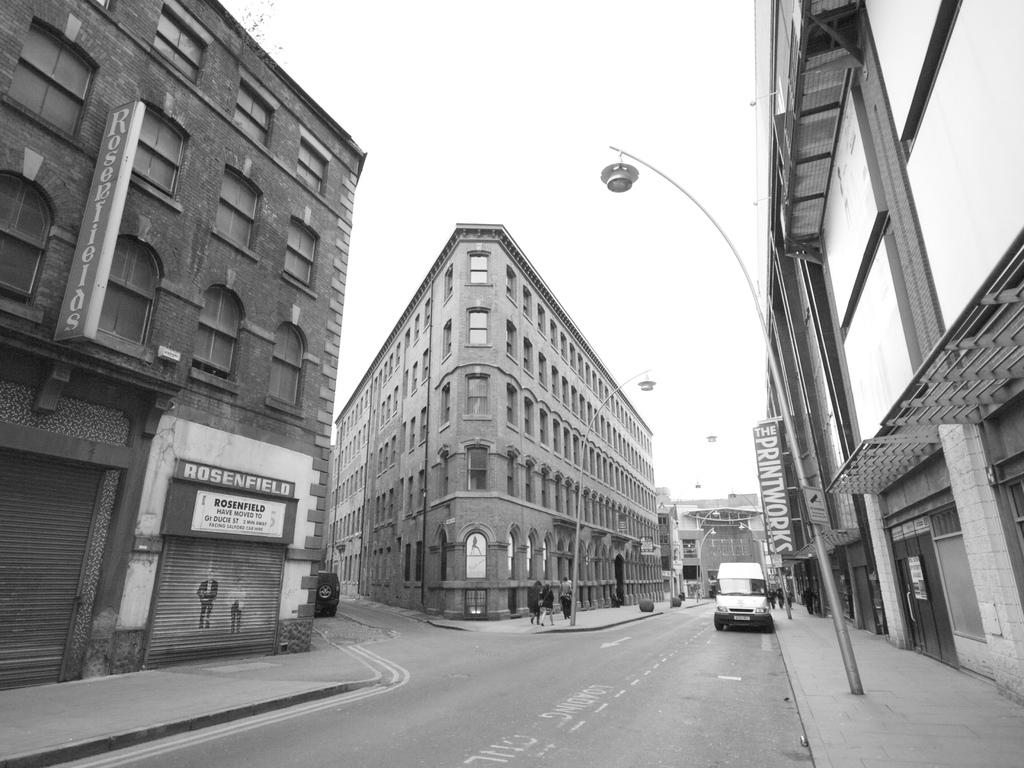Provide a one-sentence caption for the provided image. A black and white downtown scene with The Printworks sign above a sidewalk. 